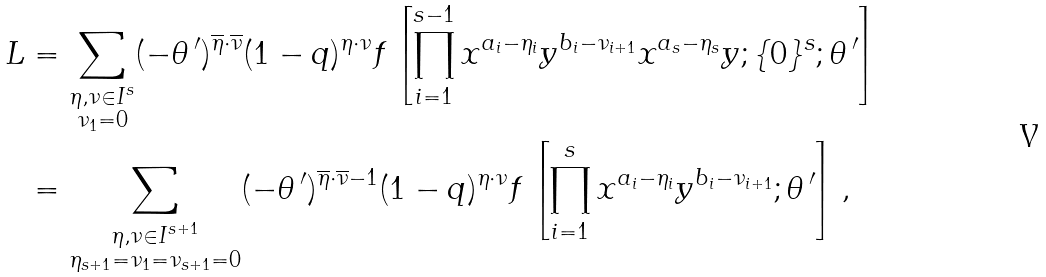<formula> <loc_0><loc_0><loc_500><loc_500>L & = \sum _ { \substack { \eta , \nu \in I ^ { s } \\ \nu _ { 1 } = 0 } } ( - \theta \, ^ { \prime } ) ^ { \overline { \eta } \cdot \overline { \nu } } ( 1 - q ) ^ { \eta \cdot \nu } f \left [ \prod _ { i = 1 } ^ { s - 1 } x ^ { a _ { i } - \eta _ { i } } y ^ { b _ { i } - \nu _ { i + 1 } } x ^ { a _ { s } - \eta _ { s } } y ; \{ 0 \} ^ { s } ; \theta \, ^ { \prime } \right ] \\ & = \sum _ { \substack { \eta , \nu \in I ^ { s + 1 } \\ \eta _ { s + 1 } = \nu _ { 1 } = \nu _ { s + 1 } = 0 } } ( - \theta \, ^ { \prime } ) ^ { \overline { \eta } \cdot \overline { \nu } - 1 } ( 1 - q ) ^ { \eta \cdot \nu } f \left [ \prod _ { i = 1 } ^ { s } x ^ { a _ { i } - \eta _ { i } } y ^ { b _ { i } - \nu _ { i + 1 } } ; \theta \, ^ { \prime } \right ] ,</formula> 